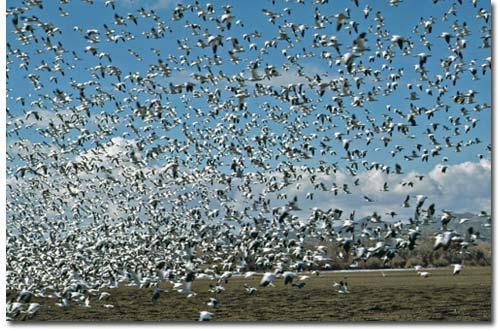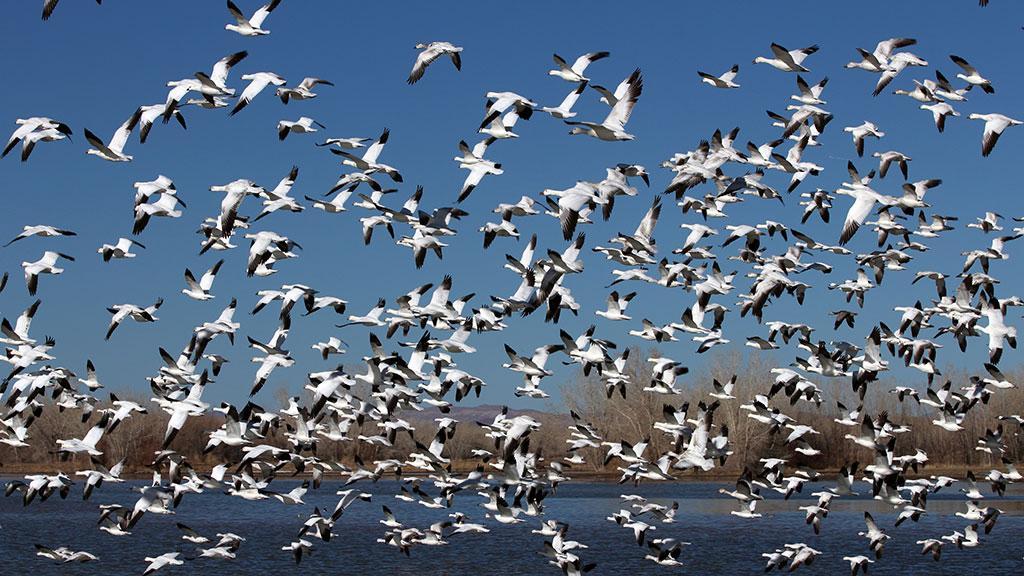The first image is the image on the left, the second image is the image on the right. Given the left and right images, does the statement "There are less than five birds in one of the pictures." hold true? Answer yes or no. No. The first image is the image on the left, the second image is the image on the right. For the images shown, is this caption "An image contains no more than five fowl." true? Answer yes or no. No. 